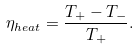Convert formula to latex. <formula><loc_0><loc_0><loc_500><loc_500>\eta _ { h e a t } = \frac { T _ { + } - T _ { - } } { T _ { + } } .</formula> 